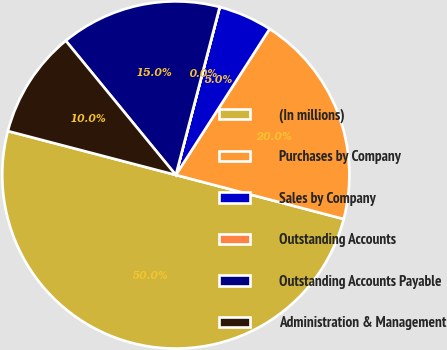Convert chart to OTSL. <chart><loc_0><loc_0><loc_500><loc_500><pie_chart><fcel>(In millions)<fcel>Purchases by Company<fcel>Sales by Company<fcel>Outstanding Accounts<fcel>Outstanding Accounts Payable<fcel>Administration & Management<nl><fcel>49.99%<fcel>20.0%<fcel>5.01%<fcel>0.01%<fcel>15.0%<fcel>10.0%<nl></chart> 